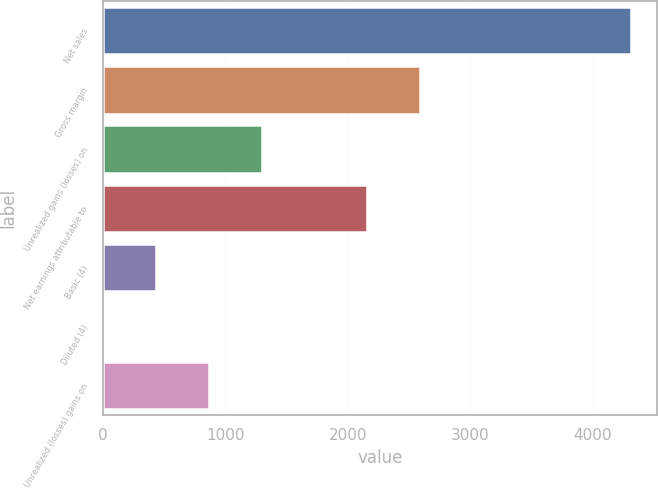Convert chart. <chart><loc_0><loc_0><loc_500><loc_500><bar_chart><fcel>Net sales<fcel>Gross margin<fcel>Unrealized gains (losses) on<fcel>Net earnings attributable to<fcel>Basic (4)<fcel>Diluted (4)<fcel>Unrealized (losses) gains on<nl><fcel>4308.3<fcel>2586.14<fcel>1294.55<fcel>2155.61<fcel>433.49<fcel>2.96<fcel>864.02<nl></chart> 